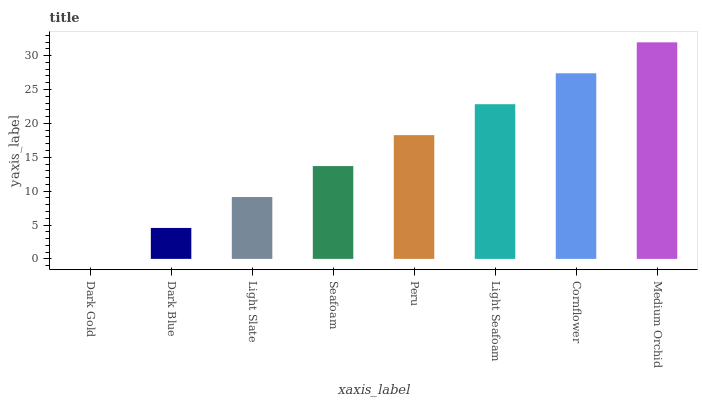Is Dark Gold the minimum?
Answer yes or no. Yes. Is Medium Orchid the maximum?
Answer yes or no. Yes. Is Dark Blue the minimum?
Answer yes or no. No. Is Dark Blue the maximum?
Answer yes or no. No. Is Dark Blue greater than Dark Gold?
Answer yes or no. Yes. Is Dark Gold less than Dark Blue?
Answer yes or no. Yes. Is Dark Gold greater than Dark Blue?
Answer yes or no. No. Is Dark Blue less than Dark Gold?
Answer yes or no. No. Is Peru the high median?
Answer yes or no. Yes. Is Seafoam the low median?
Answer yes or no. Yes. Is Light Slate the high median?
Answer yes or no. No. Is Medium Orchid the low median?
Answer yes or no. No. 